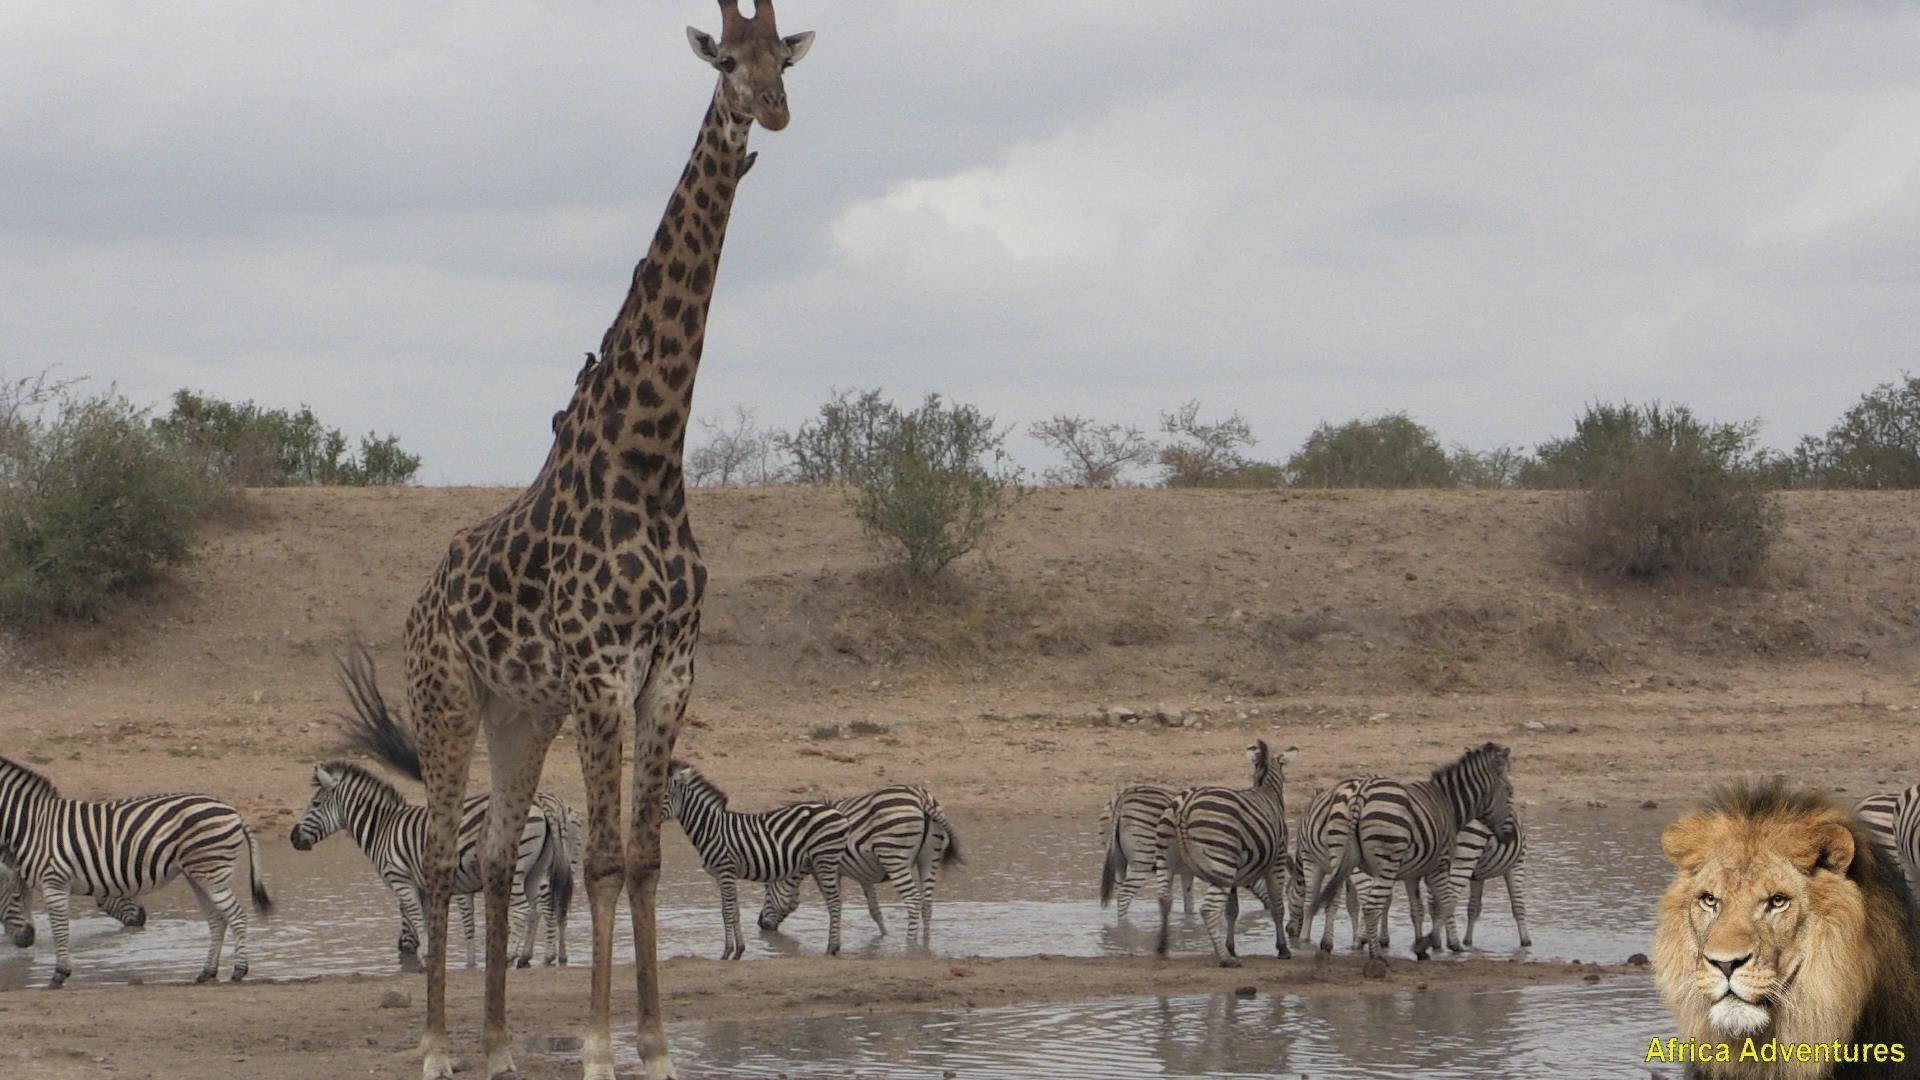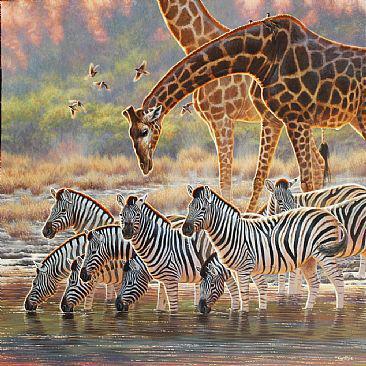The first image is the image on the left, the second image is the image on the right. Assess this claim about the two images: "The left image shows a giraffe and at least one other kind of mammal with zebra at a watering hole.". Correct or not? Answer yes or no. Yes. 